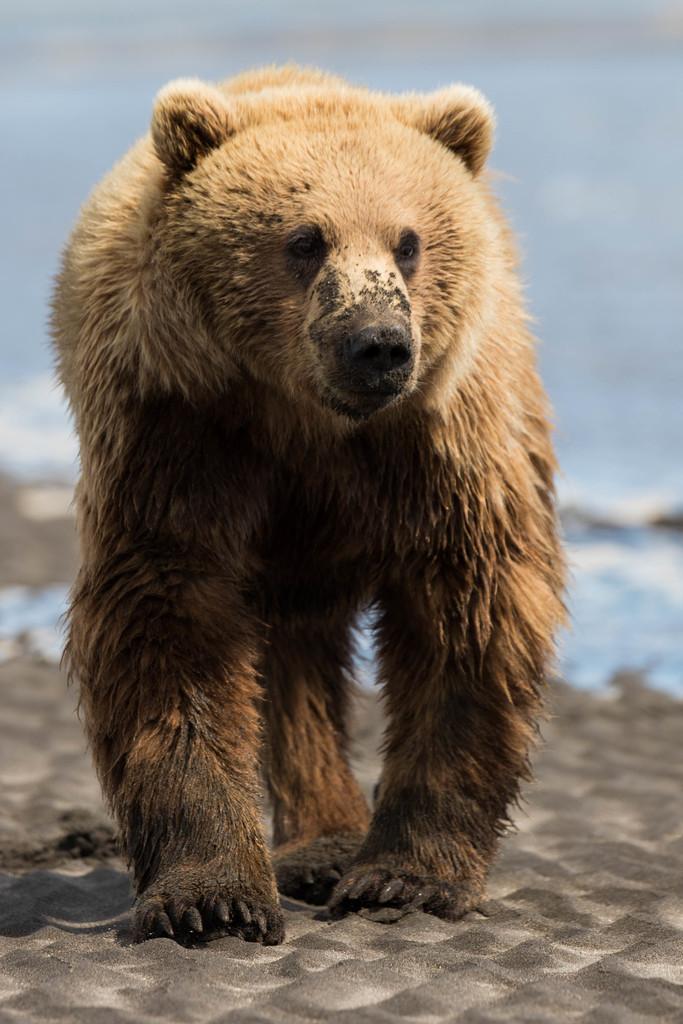Describe this image in one or two sentences. In this picture we can see bear on the sand. In the background of the image it is blurry. 